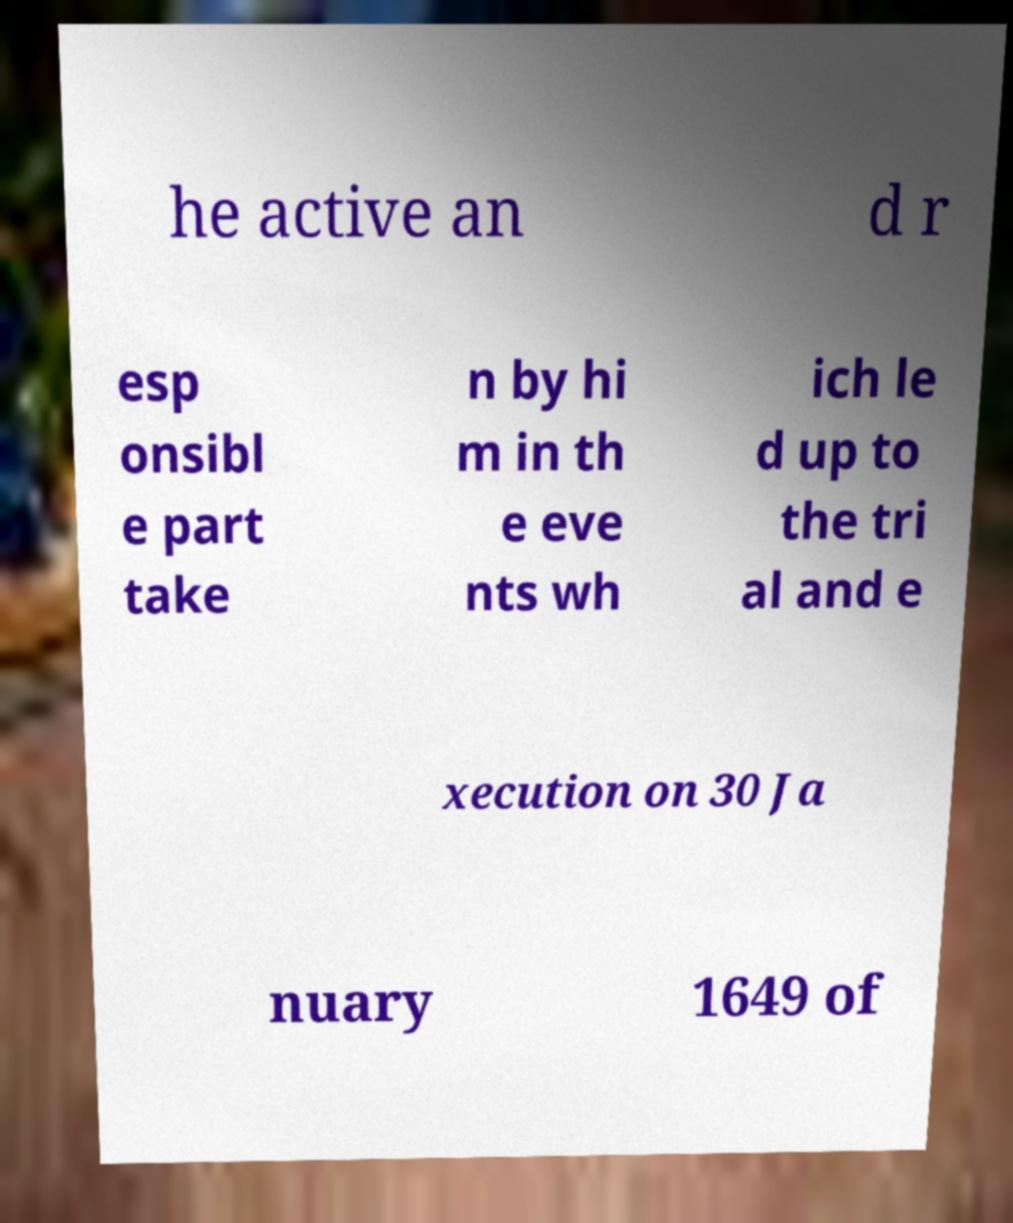There's text embedded in this image that I need extracted. Can you transcribe it verbatim? he active an d r esp onsibl e part take n by hi m in th e eve nts wh ich le d up to the tri al and e xecution on 30 Ja nuary 1649 of 